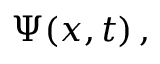Convert formula to latex. <formula><loc_0><loc_0><loc_500><loc_500>\Psi ( x , t ) \, ,</formula> 